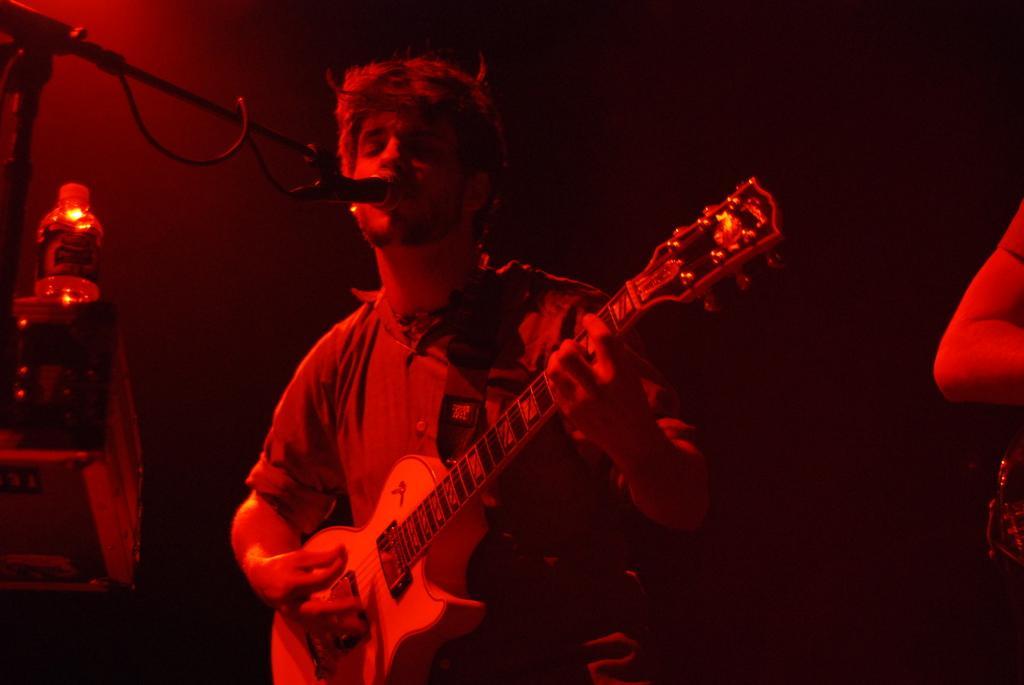Could you give a brief overview of what you see in this image? In this image I can see a man is playing a guitar in front of a microphone. 